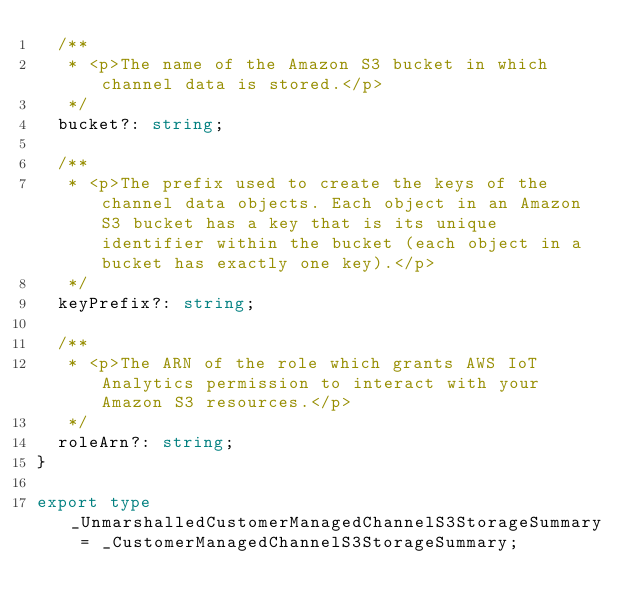Convert code to text. <code><loc_0><loc_0><loc_500><loc_500><_TypeScript_>  /**
   * <p>The name of the Amazon S3 bucket in which channel data is stored.</p>
   */
  bucket?: string;

  /**
   * <p>The prefix used to create the keys of the channel data objects. Each object in an Amazon S3 bucket has a key that is its unique identifier within the bucket (each object in a bucket has exactly one key).</p>
   */
  keyPrefix?: string;

  /**
   * <p>The ARN of the role which grants AWS IoT Analytics permission to interact with your Amazon S3 resources.</p>
   */
  roleArn?: string;
}

export type _UnmarshalledCustomerManagedChannelS3StorageSummary = _CustomerManagedChannelS3StorageSummary;
</code> 